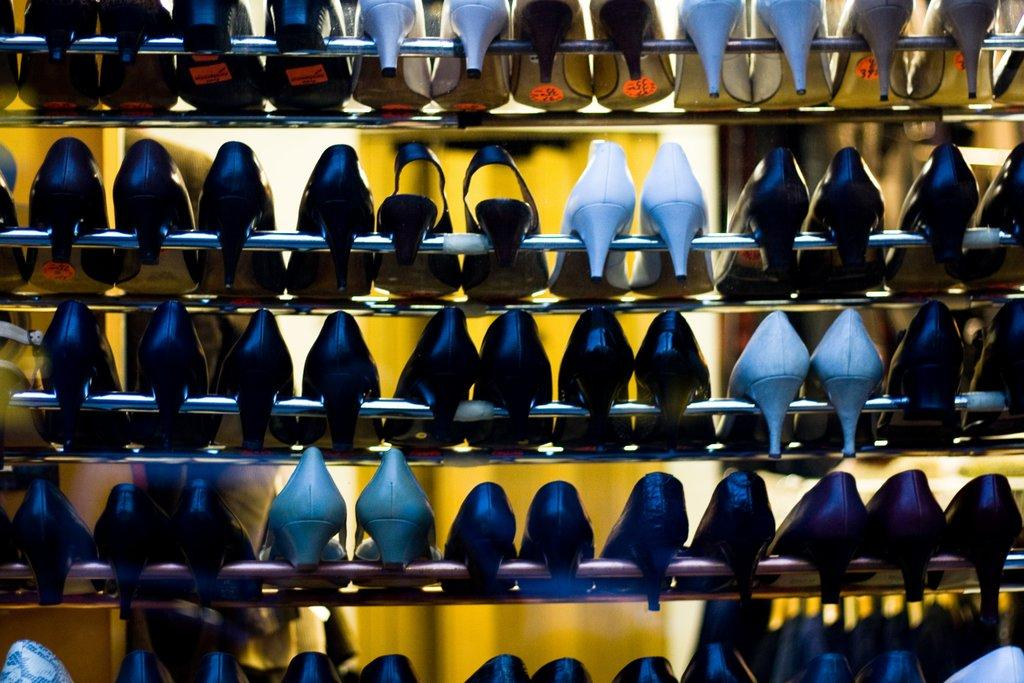What objects are present in the image? There are shoes in the image. How are the shoes arranged in the image? The shoes are on racks. What is the purpose of the shoes in the image? The purpose of the shoes cannot be determined from the image alone, as it does not show who might wear them or for what activity. 